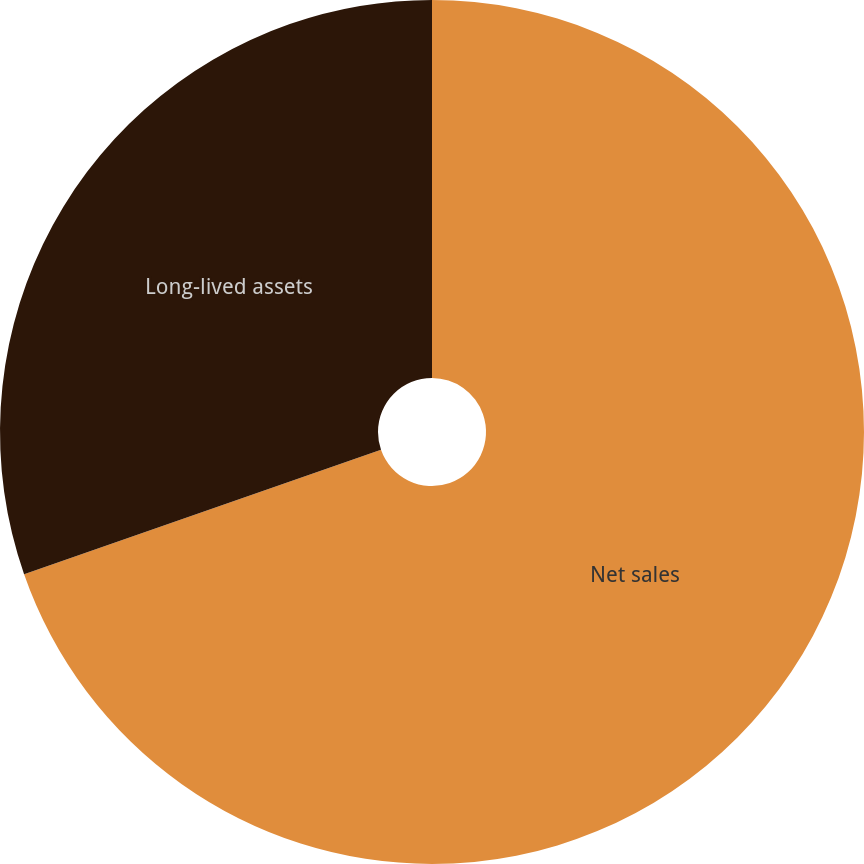Convert chart. <chart><loc_0><loc_0><loc_500><loc_500><pie_chart><fcel>Net sales<fcel>Long-lived assets<nl><fcel>69.66%<fcel>30.34%<nl></chart> 